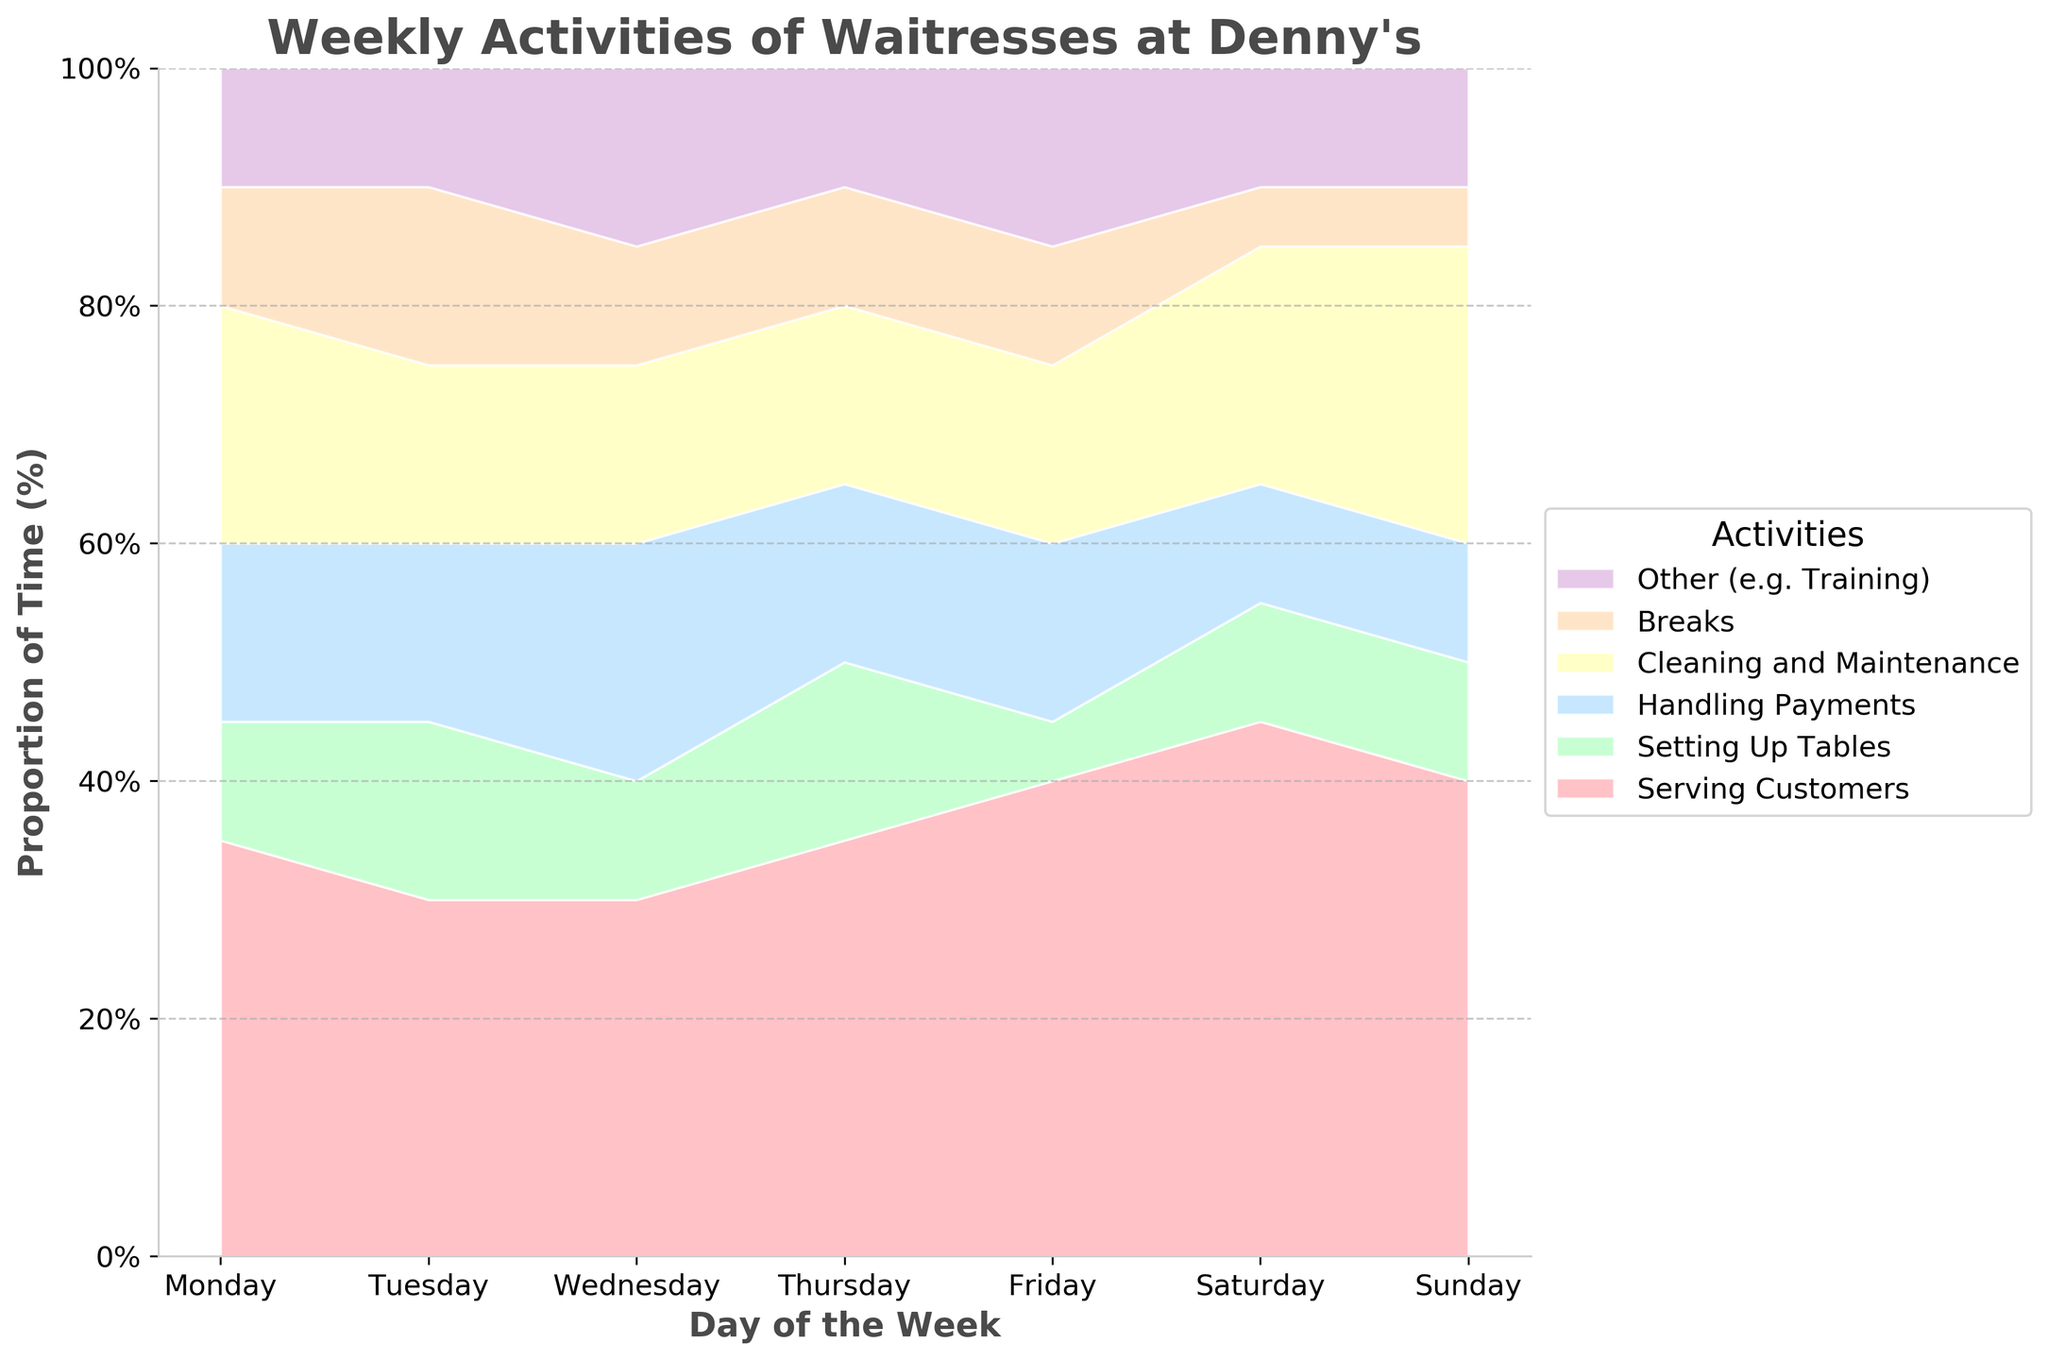What is the title of the chart? The title is located at the top of the chart. It usually describes the content or purpose of the figure.
Answer: Weekly Activities of Waitresses at Denny's Which day has the highest proportion of time spent on Serving Customers? By visually comparing the sections of the chart, one can see that the section representing "Serving Customers" is largest on Saturday.
Answer: Saturday How many different activities are shown in the chart? Count the different colored areas in the stack plot, each representing a different activity.
Answer: 6 On which day is the least time spent on Handling Payments? By comparing the proportions of the "Handling Payments" area across the days, the smallest section is on Saturday.
Answer: Saturday What is the proportion of time spent on Breaks on Tuesday? Look for the section labeled "Breaks" on Tuesday and estimate the percentage. The data suggests it is 15%.
Answer: 15% How much more time is spent on Cleaning and Maintenance on Sunday compared to Monday? The proportion of Cleaning and Maintenance is 25% on Sunday and 20% on Monday. The difference is 25% - 20%.
Answer: 5% Which two activities take up equal proportions of time on any given day? By comparing the size of the sections visually, "Serving Customers" and "Setting Up Tables" each take up 10% of Friday's total time.
Answer: Setting Up Tables and Other on Friday Which day has the lowest total time spent on Breaks and Other (Training)? Add the proportions of Breaks and Other for each day and compare. The smallest total is for Saturday with 5% + 10% = 15%.
Answer: Saturday On what day do waitresses spend the most equal time among all activities? Find the day where the sections are most similar in size. Tuesday has relatively balanced sections with values close to each other.
Answer: Tuesday What is the greatest difference in time spent on Serving Customers between any two days? Compare the percentages for "Serving Customers" across all days and find the largest difference. Saturday (45%) - Tuesday (30%) gives the biggest difference of 15%.
Answer: 15% 